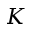Convert formula to latex. <formula><loc_0><loc_0><loc_500><loc_500>K</formula> 